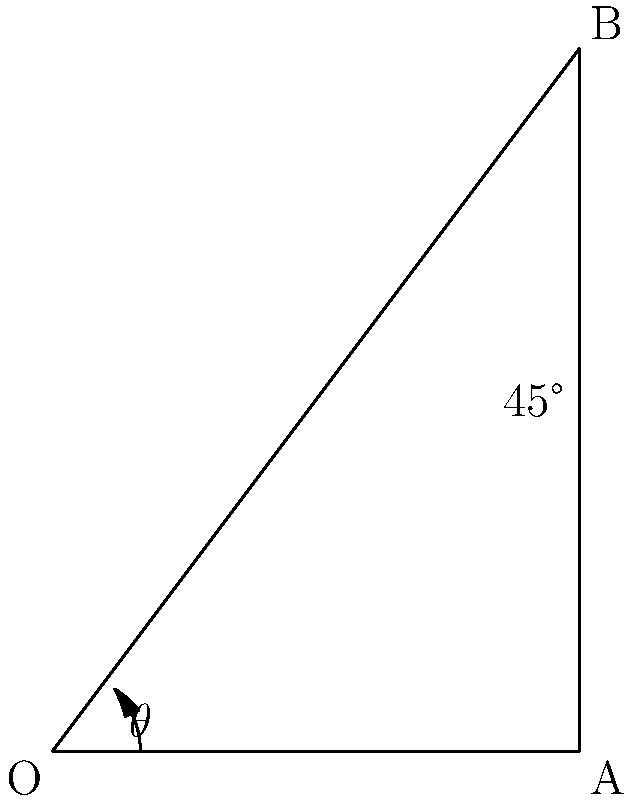During a rebound, you need to determine the optimal angle for your jump to reach maximum height. Given that the angle between the ground and your jump trajectory is 45°, what is the angle $\theta$ between your initial upward velocity vector and the horizontal plane? Let's approach this step-by-step:

1) In the diagram, OA represents the horizontal plane, and OB represents your jump trajectory.

2) We're given that the angle between OA and OB is 45°.

3) In a right-angled triangle, the sum of all angles is 180°.

4) The angle at A is a right angle (90°), as it represents the vertical direction perpendicular to the ground.

5) Let's call the angle we're looking for (between OB and OA) $\theta$.

6) We can set up an equation:
   $90° + 45° + \theta = 180°$

7) Simplifying:
   $135° + \theta = 180°$

8) Solving for $\theta$:
   $\theta = 180° - 135° = 45°$

Therefore, the angle $\theta$ between your initial upward velocity vector and the horizontal plane is 45°.

This result aligns with the physics principle that the optimal angle for projectile motion to achieve maximum height and distance (in the absence of air resistance) is indeed 45°.
Answer: 45° 